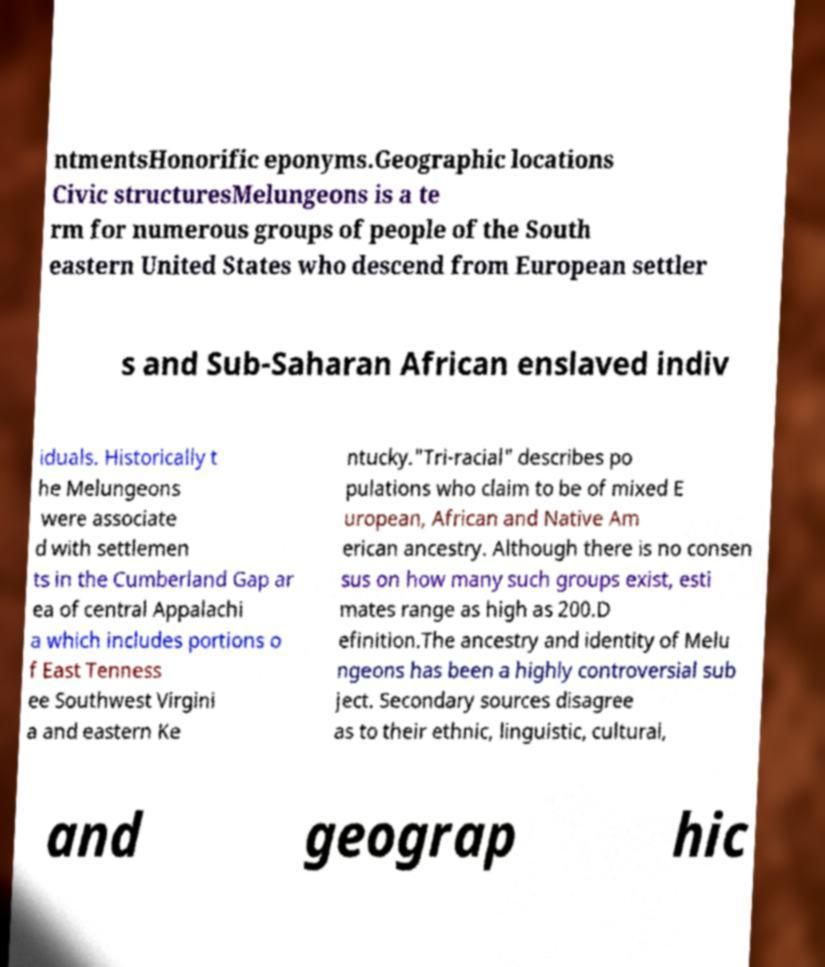Could you assist in decoding the text presented in this image and type it out clearly? ntmentsHonorific eponyms.Geographic locations Civic structuresMelungeons is a te rm for numerous groups of people of the South eastern United States who descend from European settler s and Sub-Saharan African enslaved indiv iduals. Historically t he Melungeons were associate d with settlemen ts in the Cumberland Gap ar ea of central Appalachi a which includes portions o f East Tenness ee Southwest Virgini a and eastern Ke ntucky."Tri-racial" describes po pulations who claim to be of mixed E uropean, African and Native Am erican ancestry. Although there is no consen sus on how many such groups exist, esti mates range as high as 200.D efinition.The ancestry and identity of Melu ngeons has been a highly controversial sub ject. Secondary sources disagree as to their ethnic, linguistic, cultural, and geograp hic 